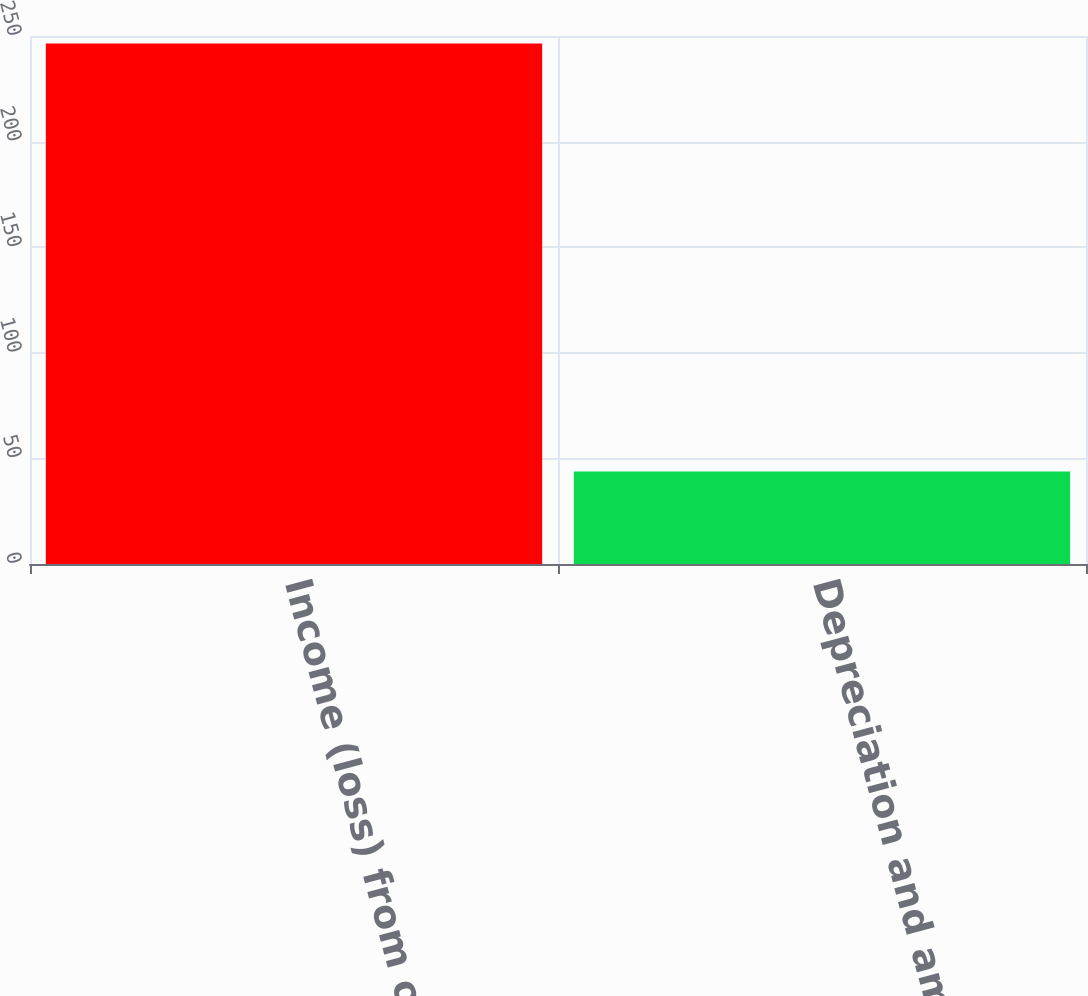<chart> <loc_0><loc_0><loc_500><loc_500><bar_chart><fcel>Income (loss) from operations<fcel>Depreciation and amortization<nl><fcel>246.5<fcel>43.8<nl></chart> 